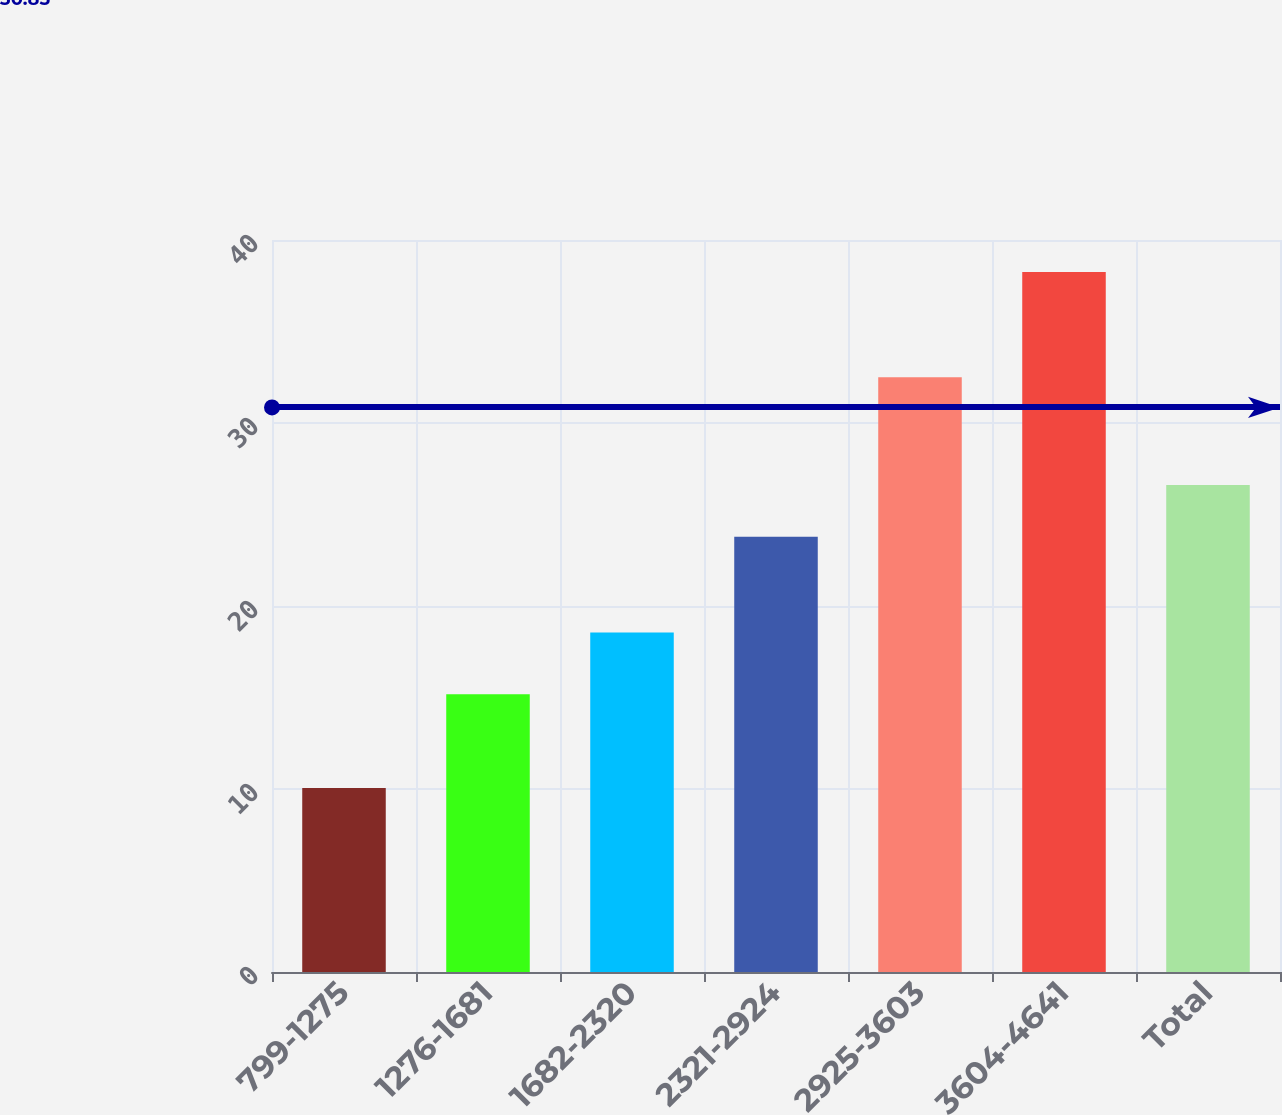Convert chart. <chart><loc_0><loc_0><loc_500><loc_500><bar_chart><fcel>799-1275<fcel>1276-1681<fcel>1682-2320<fcel>2321-2924<fcel>2925-3603<fcel>3604-4641<fcel>Total<nl><fcel>10.06<fcel>15.18<fcel>18.55<fcel>23.79<fcel>32.5<fcel>38.25<fcel>26.61<nl></chart> 